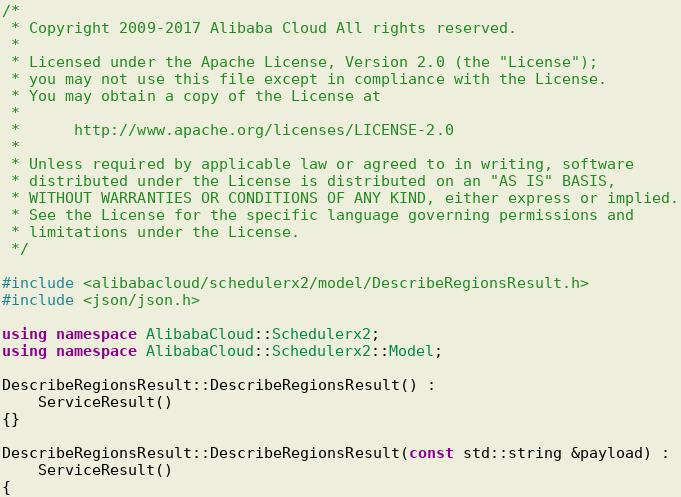Convert code to text. <code><loc_0><loc_0><loc_500><loc_500><_C++_>/*
 * Copyright 2009-2017 Alibaba Cloud All rights reserved.
 * 
 * Licensed under the Apache License, Version 2.0 (the "License");
 * you may not use this file except in compliance with the License.
 * You may obtain a copy of the License at
 * 
 *      http://www.apache.org/licenses/LICENSE-2.0
 * 
 * Unless required by applicable law or agreed to in writing, software
 * distributed under the License is distributed on an "AS IS" BASIS,
 * WITHOUT WARRANTIES OR CONDITIONS OF ANY KIND, either express or implied.
 * See the License for the specific language governing permissions and
 * limitations under the License.
 */

#include <alibabacloud/schedulerx2/model/DescribeRegionsResult.h>
#include <json/json.h>

using namespace AlibabaCloud::Schedulerx2;
using namespace AlibabaCloud::Schedulerx2::Model;

DescribeRegionsResult::DescribeRegionsResult() :
	ServiceResult()
{}

DescribeRegionsResult::DescribeRegionsResult(const std::string &payload) :
	ServiceResult()
{</code> 